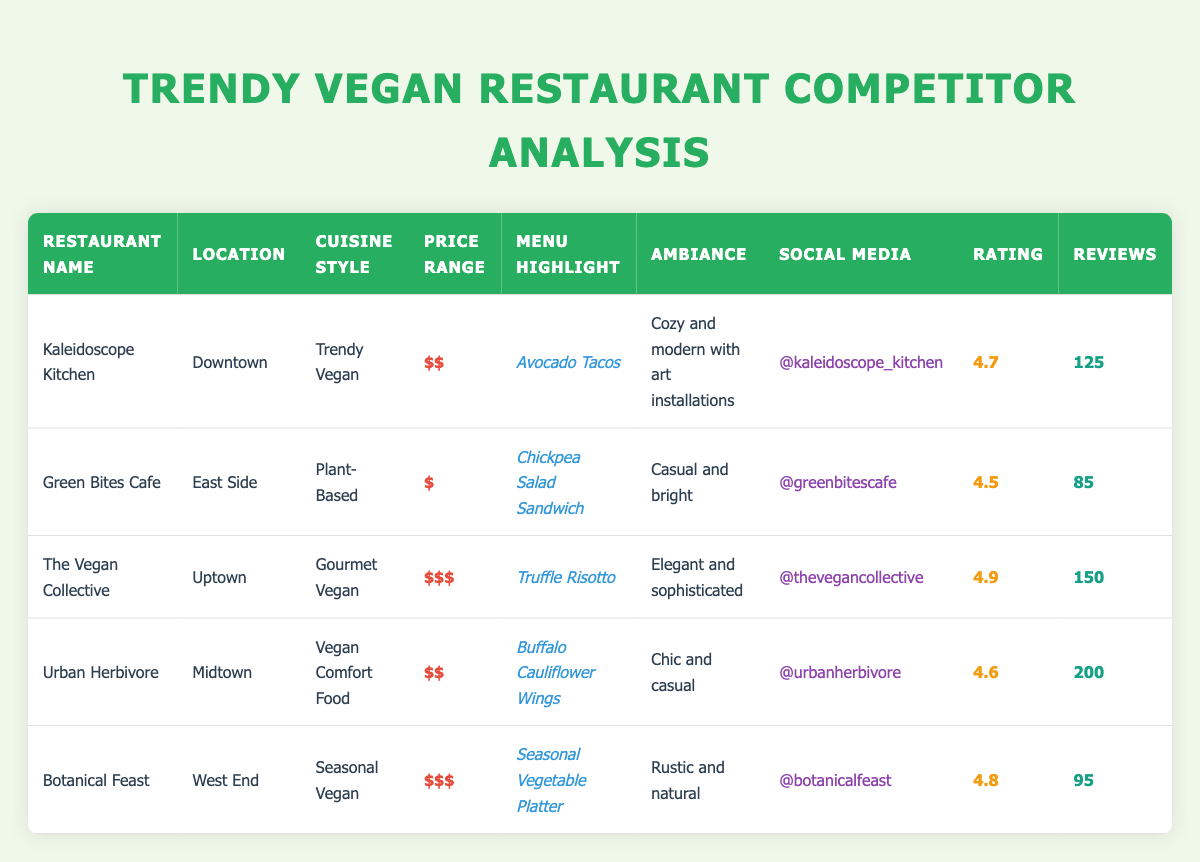What is the highest-rated restaurant among the competitors? The table shows the ratings of each restaurant. The highest rating is 4.9, which belongs to "The Vegan Collective."
Answer: The Vegan Collective Which restaurant has the most customer reviews? By comparing the customer reviews column, "Urban Herbivore" has 200 reviews, which is more than any other restaurant listed.
Answer: Urban Herbivore What is the average price range of the restaurants listed in the table? The price ranges are: $$, $, $$$, $$, $$$. We can assign values: $ = 1, $$ = 2, $$$ = 3. This gives us: (2 + 1 + 3 + 2 + 3) / 5 = 11 / 5 = 2.2. This corresponds to approximately $$ for the average.
Answer: $$ Are all restaurants in the same cuisine style? The table lists different cuisine styles, including "Trendy Vegan," "Plant-Based," "Gourmet Vegan," "Vegan Comfort Food," and "Seasonal Vegan." Since there is more than one style, the answer is no.
Answer: No What is the difference in customer reviews between the highest and lowest-rated restaurant? The highest-rated restaurant, "The Vegan Collective," has 150 reviews, and the lowest-rated restaurant, "Green Bites Cafe," has 85 reviews. The difference is 150 - 85 = 65.
Answer: 65 